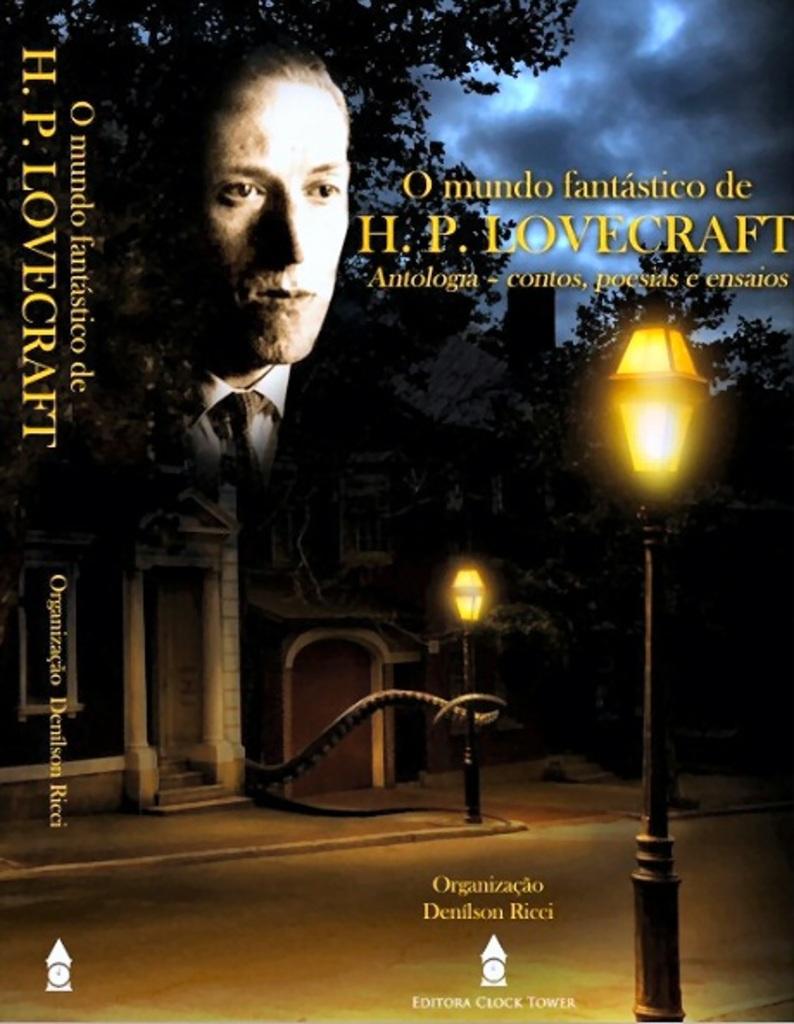What is the title of this book?
Keep it short and to the point. O mundo fantastico de h.p. lovecraft. Who released this publication?
Make the answer very short. H.p. lovecraft. 